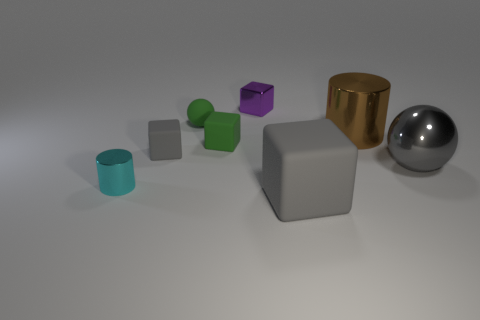Subtract all green cubes. How many cubes are left? 3 Add 1 tiny purple metallic things. How many objects exist? 9 Subtract all cyan balls. How many gray cubes are left? 2 Subtract all cylinders. How many objects are left? 6 Subtract all purple cubes. How many cubes are left? 3 Subtract all big brown metal cylinders. Subtract all large metal balls. How many objects are left? 6 Add 4 brown objects. How many brown objects are left? 5 Add 8 gray shiny cylinders. How many gray shiny cylinders exist? 8 Subtract 0 red cylinders. How many objects are left? 8 Subtract all brown cylinders. Subtract all red balls. How many cylinders are left? 1 